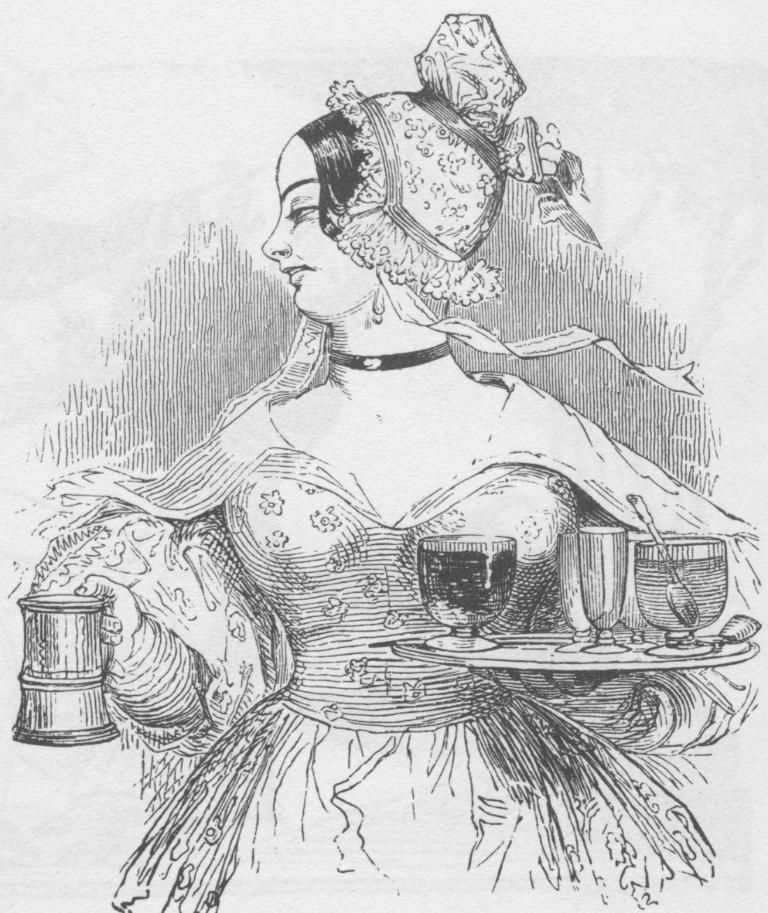What is depicted in the image? There is a sketch of a woman in the image. What is the woman holding in the sketch? The woman is holding a jug and a plate. What items can be seen on the plate? The plate contains glasses and bowls. Is there any utensil visible in the image? Yes, there is a spoon in the bowl on the plate. What type of comb is the woman using in the image? There is no comb present in the image; the woman is holding a jug and a plate. Are there any scissors visible in the image? No, there are no scissors visible in the image. 